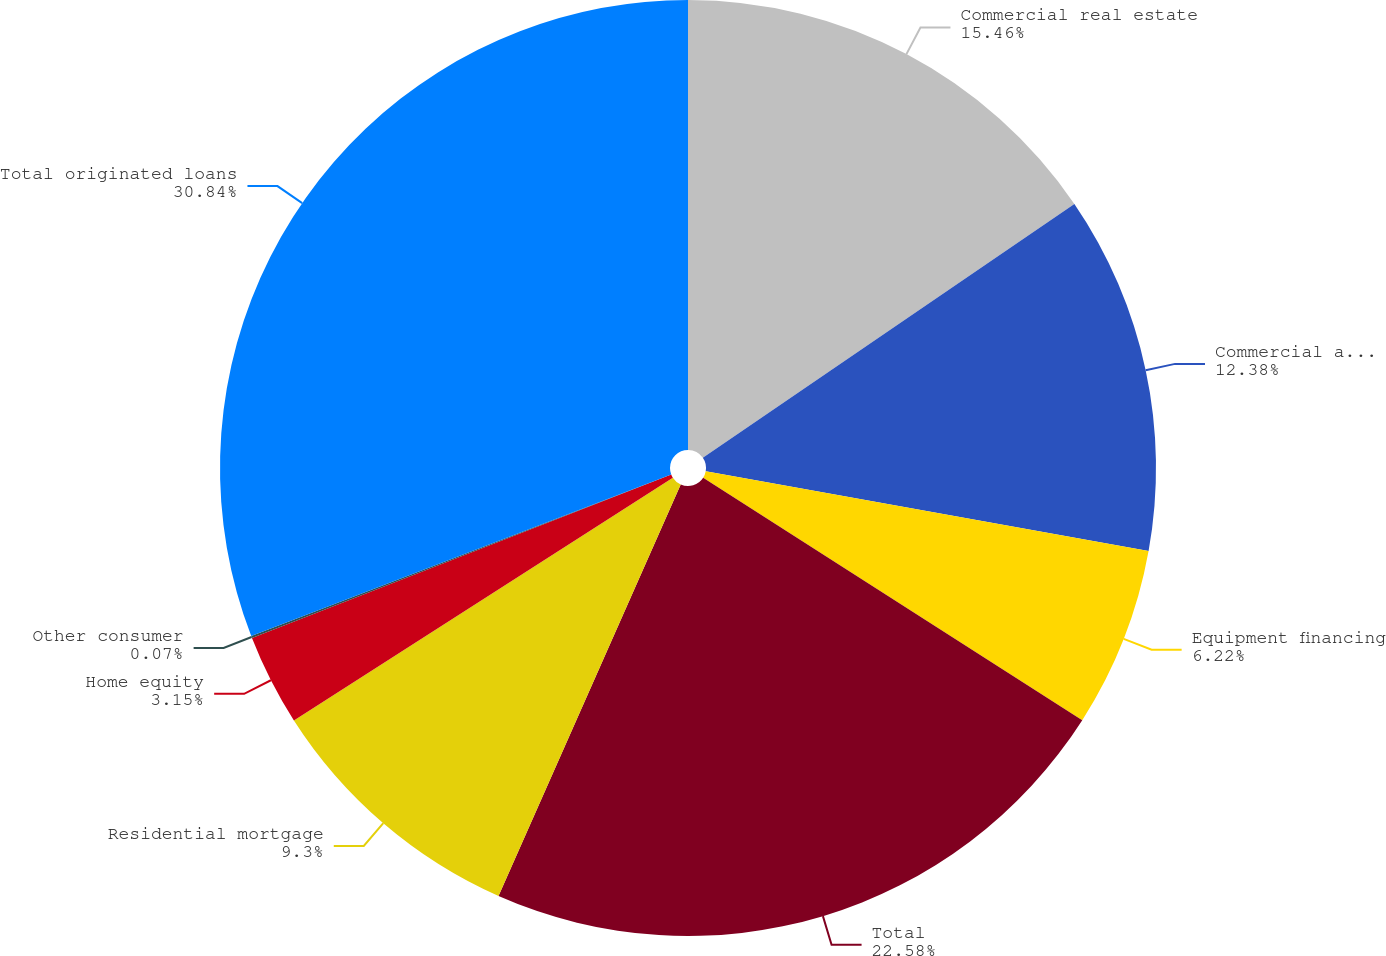Convert chart to OTSL. <chart><loc_0><loc_0><loc_500><loc_500><pie_chart><fcel>Commercial real estate<fcel>Commercial and industrial<fcel>Equipment financing<fcel>Total<fcel>Residential mortgage<fcel>Home equity<fcel>Other consumer<fcel>Total originated loans<nl><fcel>15.46%<fcel>12.38%<fcel>6.22%<fcel>22.58%<fcel>9.3%<fcel>3.15%<fcel>0.07%<fcel>30.85%<nl></chart> 